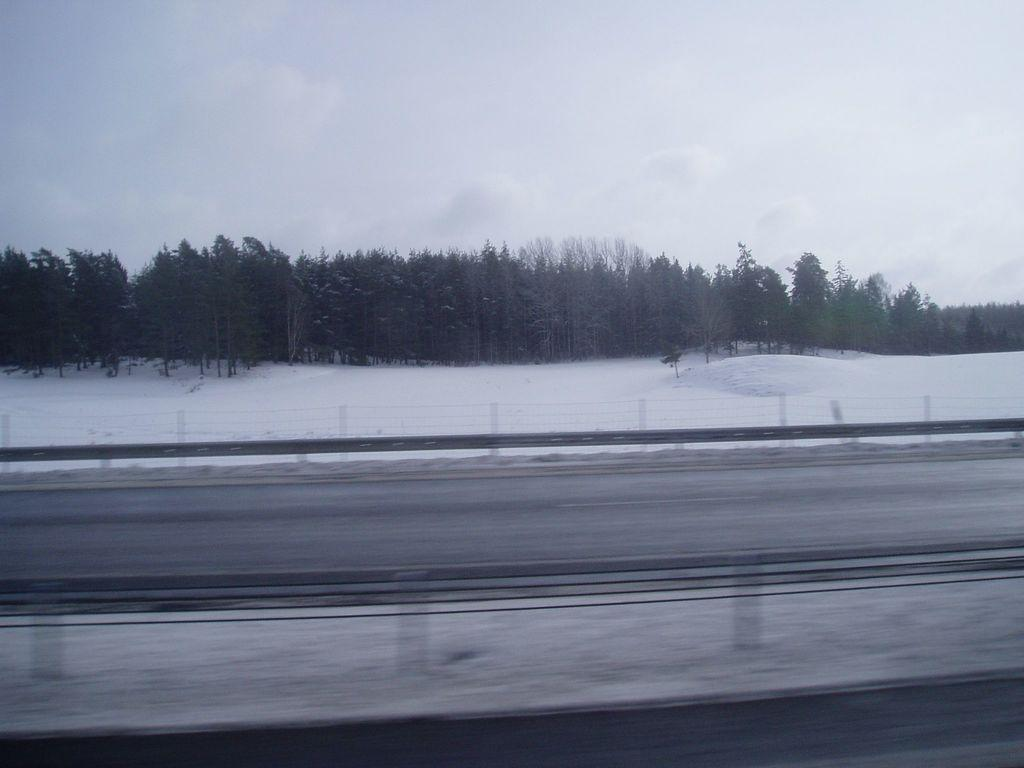What is the main feature of the image? There is a road in the image. What is located beside the road? There is a fence beside the road. What is the condition of the ground near the fence? The ground is covered with snow beside the fence. What can be seen in the background of the image? There are trees in the background of the image. What type of quill can be seen in the image? There is no quill present in the image. How does the snow make the people in the image feel? The image does not depict any people, so it cannot be determined how the snow affects their feelings. 